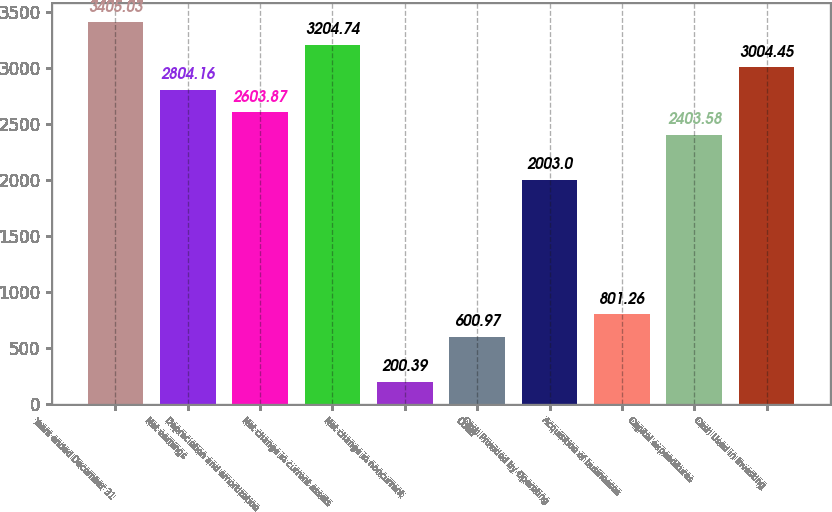Convert chart to OTSL. <chart><loc_0><loc_0><loc_500><loc_500><bar_chart><fcel>Years ended December 31<fcel>Net earnings<fcel>Depreciation and amortization<fcel>Net change in current assets<fcel>Net change in noncurrent<fcel>Other<fcel>Cash Provided by Operating<fcel>Acquisition of businesses<fcel>Capital expenditures<fcel>Cash Used in Investing<nl><fcel>3405.03<fcel>2804.16<fcel>2603.87<fcel>3204.74<fcel>200.39<fcel>600.97<fcel>2003<fcel>801.26<fcel>2403.58<fcel>3004.45<nl></chart> 